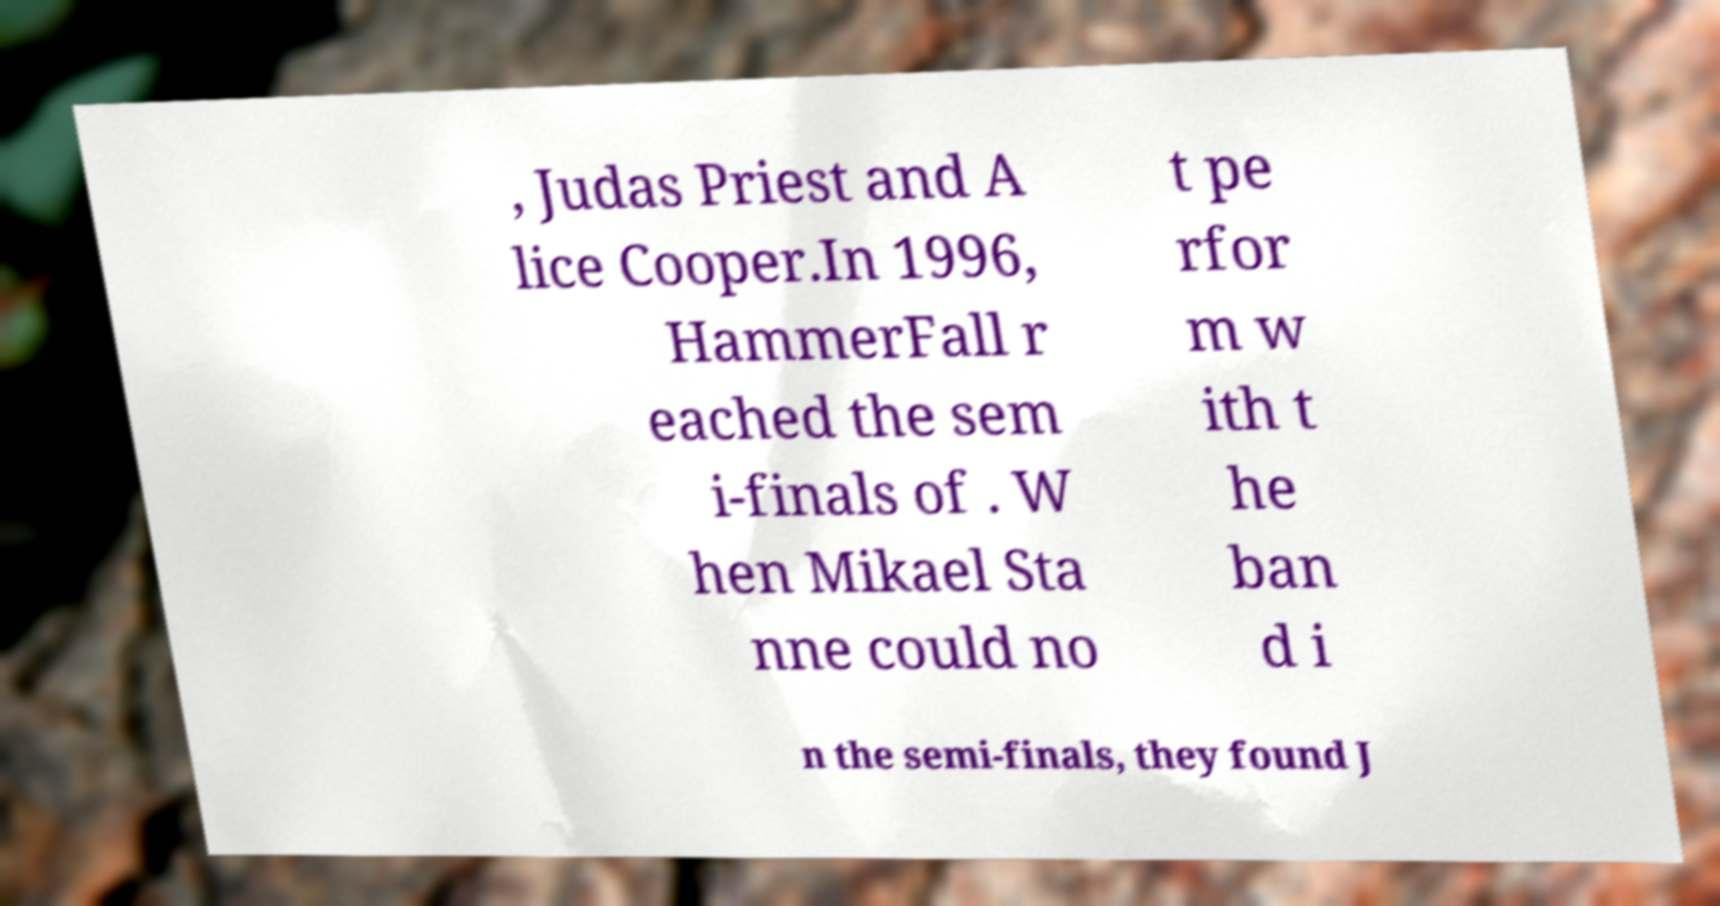Please read and relay the text visible in this image. What does it say? , Judas Priest and A lice Cooper.In 1996, HammerFall r eached the sem i-finals of . W hen Mikael Sta nne could no t pe rfor m w ith t he ban d i n the semi-finals, they found J 